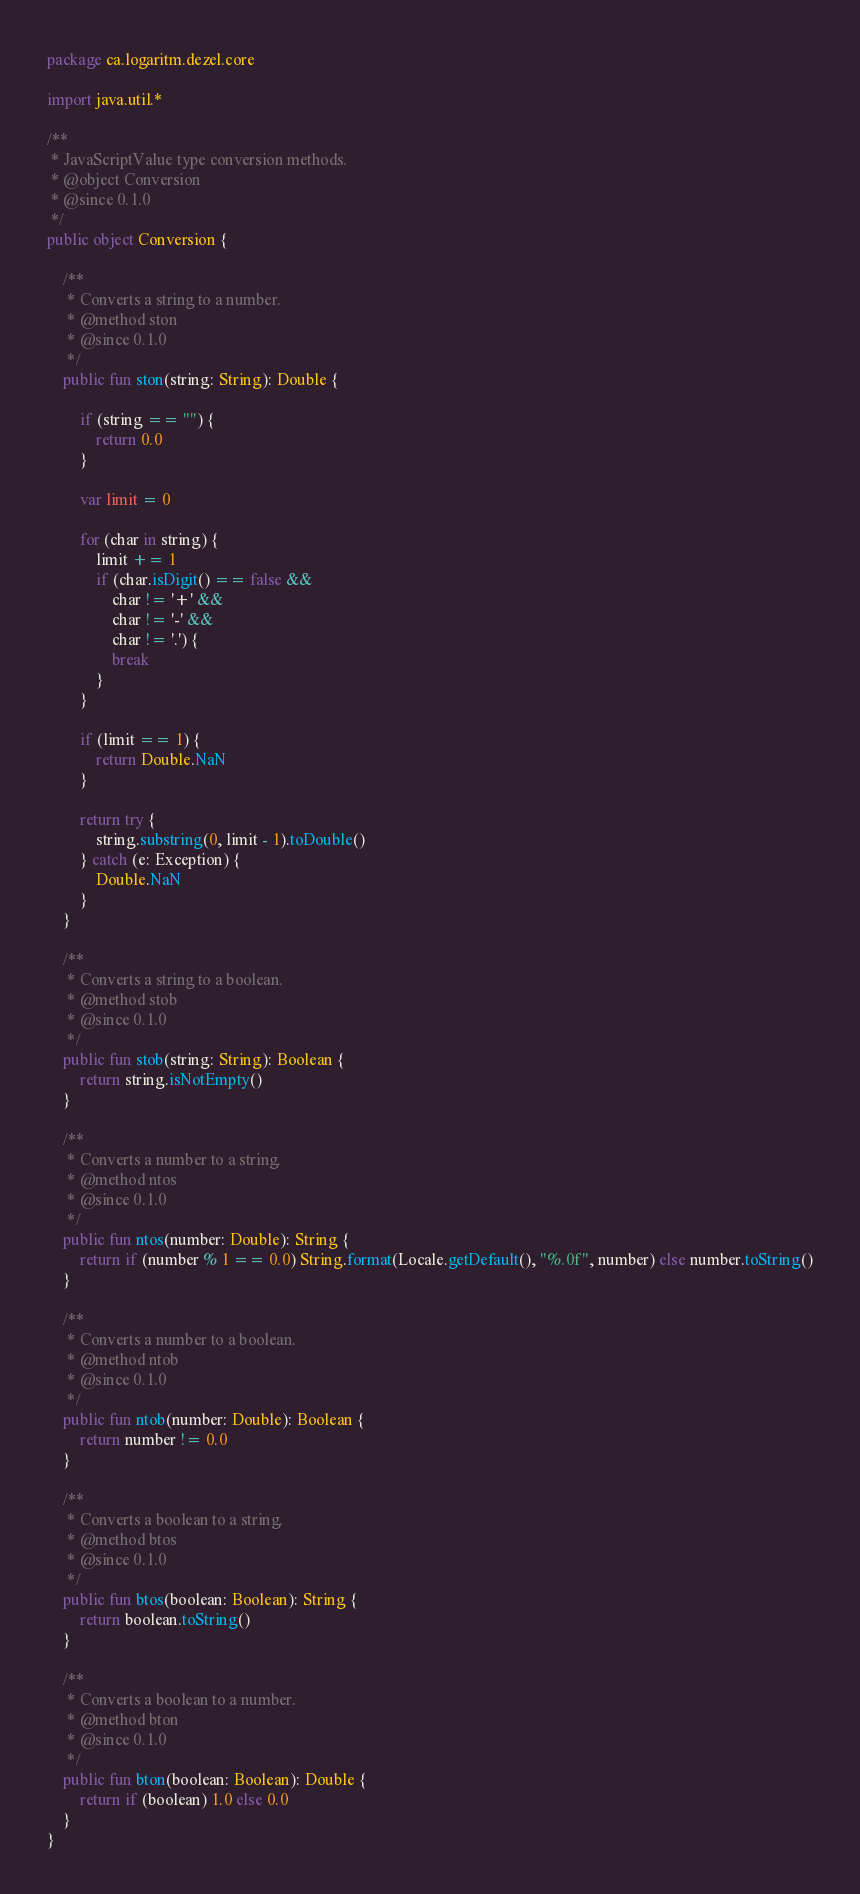Convert code to text. <code><loc_0><loc_0><loc_500><loc_500><_Kotlin_>package ca.logaritm.dezel.core

import java.util.*

/**
 * JavaScriptValue type conversion methods.
 * @object Conversion
 * @since 0.1.0
 */
public object Conversion {

	/**
	 * Converts a string to a number.
	 * @method ston
	 * @since 0.1.0
	 */
	public fun ston(string: String): Double {

		if (string == "") {
			return 0.0
		}

		var limit = 0

		for (char in string) {
			limit += 1
			if (char.isDigit() == false &&
				char != '+' &&
				char != '-' &&
				char != '.') {
				break
			}
		}

		if (limit == 1) {
			return Double.NaN
		}

		return try {
			string.substring(0, limit - 1).toDouble()
		} catch (e: Exception) {
			Double.NaN
		}
	}

	/**
	 * Converts a string to a boolean.
	 * @method stob
	 * @since 0.1.0
	 */
	public fun stob(string: String): Boolean {
		return string.isNotEmpty()
	}

	/**
	 * Converts a number to a string.
	 * @method ntos
	 * @since 0.1.0
	 */
	public fun ntos(number: Double): String {
		return if (number % 1 == 0.0) String.format(Locale.getDefault(), "%.0f", number) else number.toString()
	}

	/**
	 * Converts a number to a boolean.
	 * @method ntob
	 * @since 0.1.0
	 */
	public fun ntob(number: Double): Boolean {
		return number != 0.0
	}

	/**
	 * Converts a boolean to a string.
	 * @method btos
	 * @since 0.1.0
	 */
	public fun btos(boolean: Boolean): String {
		return boolean.toString()
	}

	/**
	 * Converts a boolean to a number.
	 * @method bton
	 * @since 0.1.0
	 */
	public fun bton(boolean: Boolean): Double {
		return if (boolean) 1.0 else 0.0
	}
}</code> 